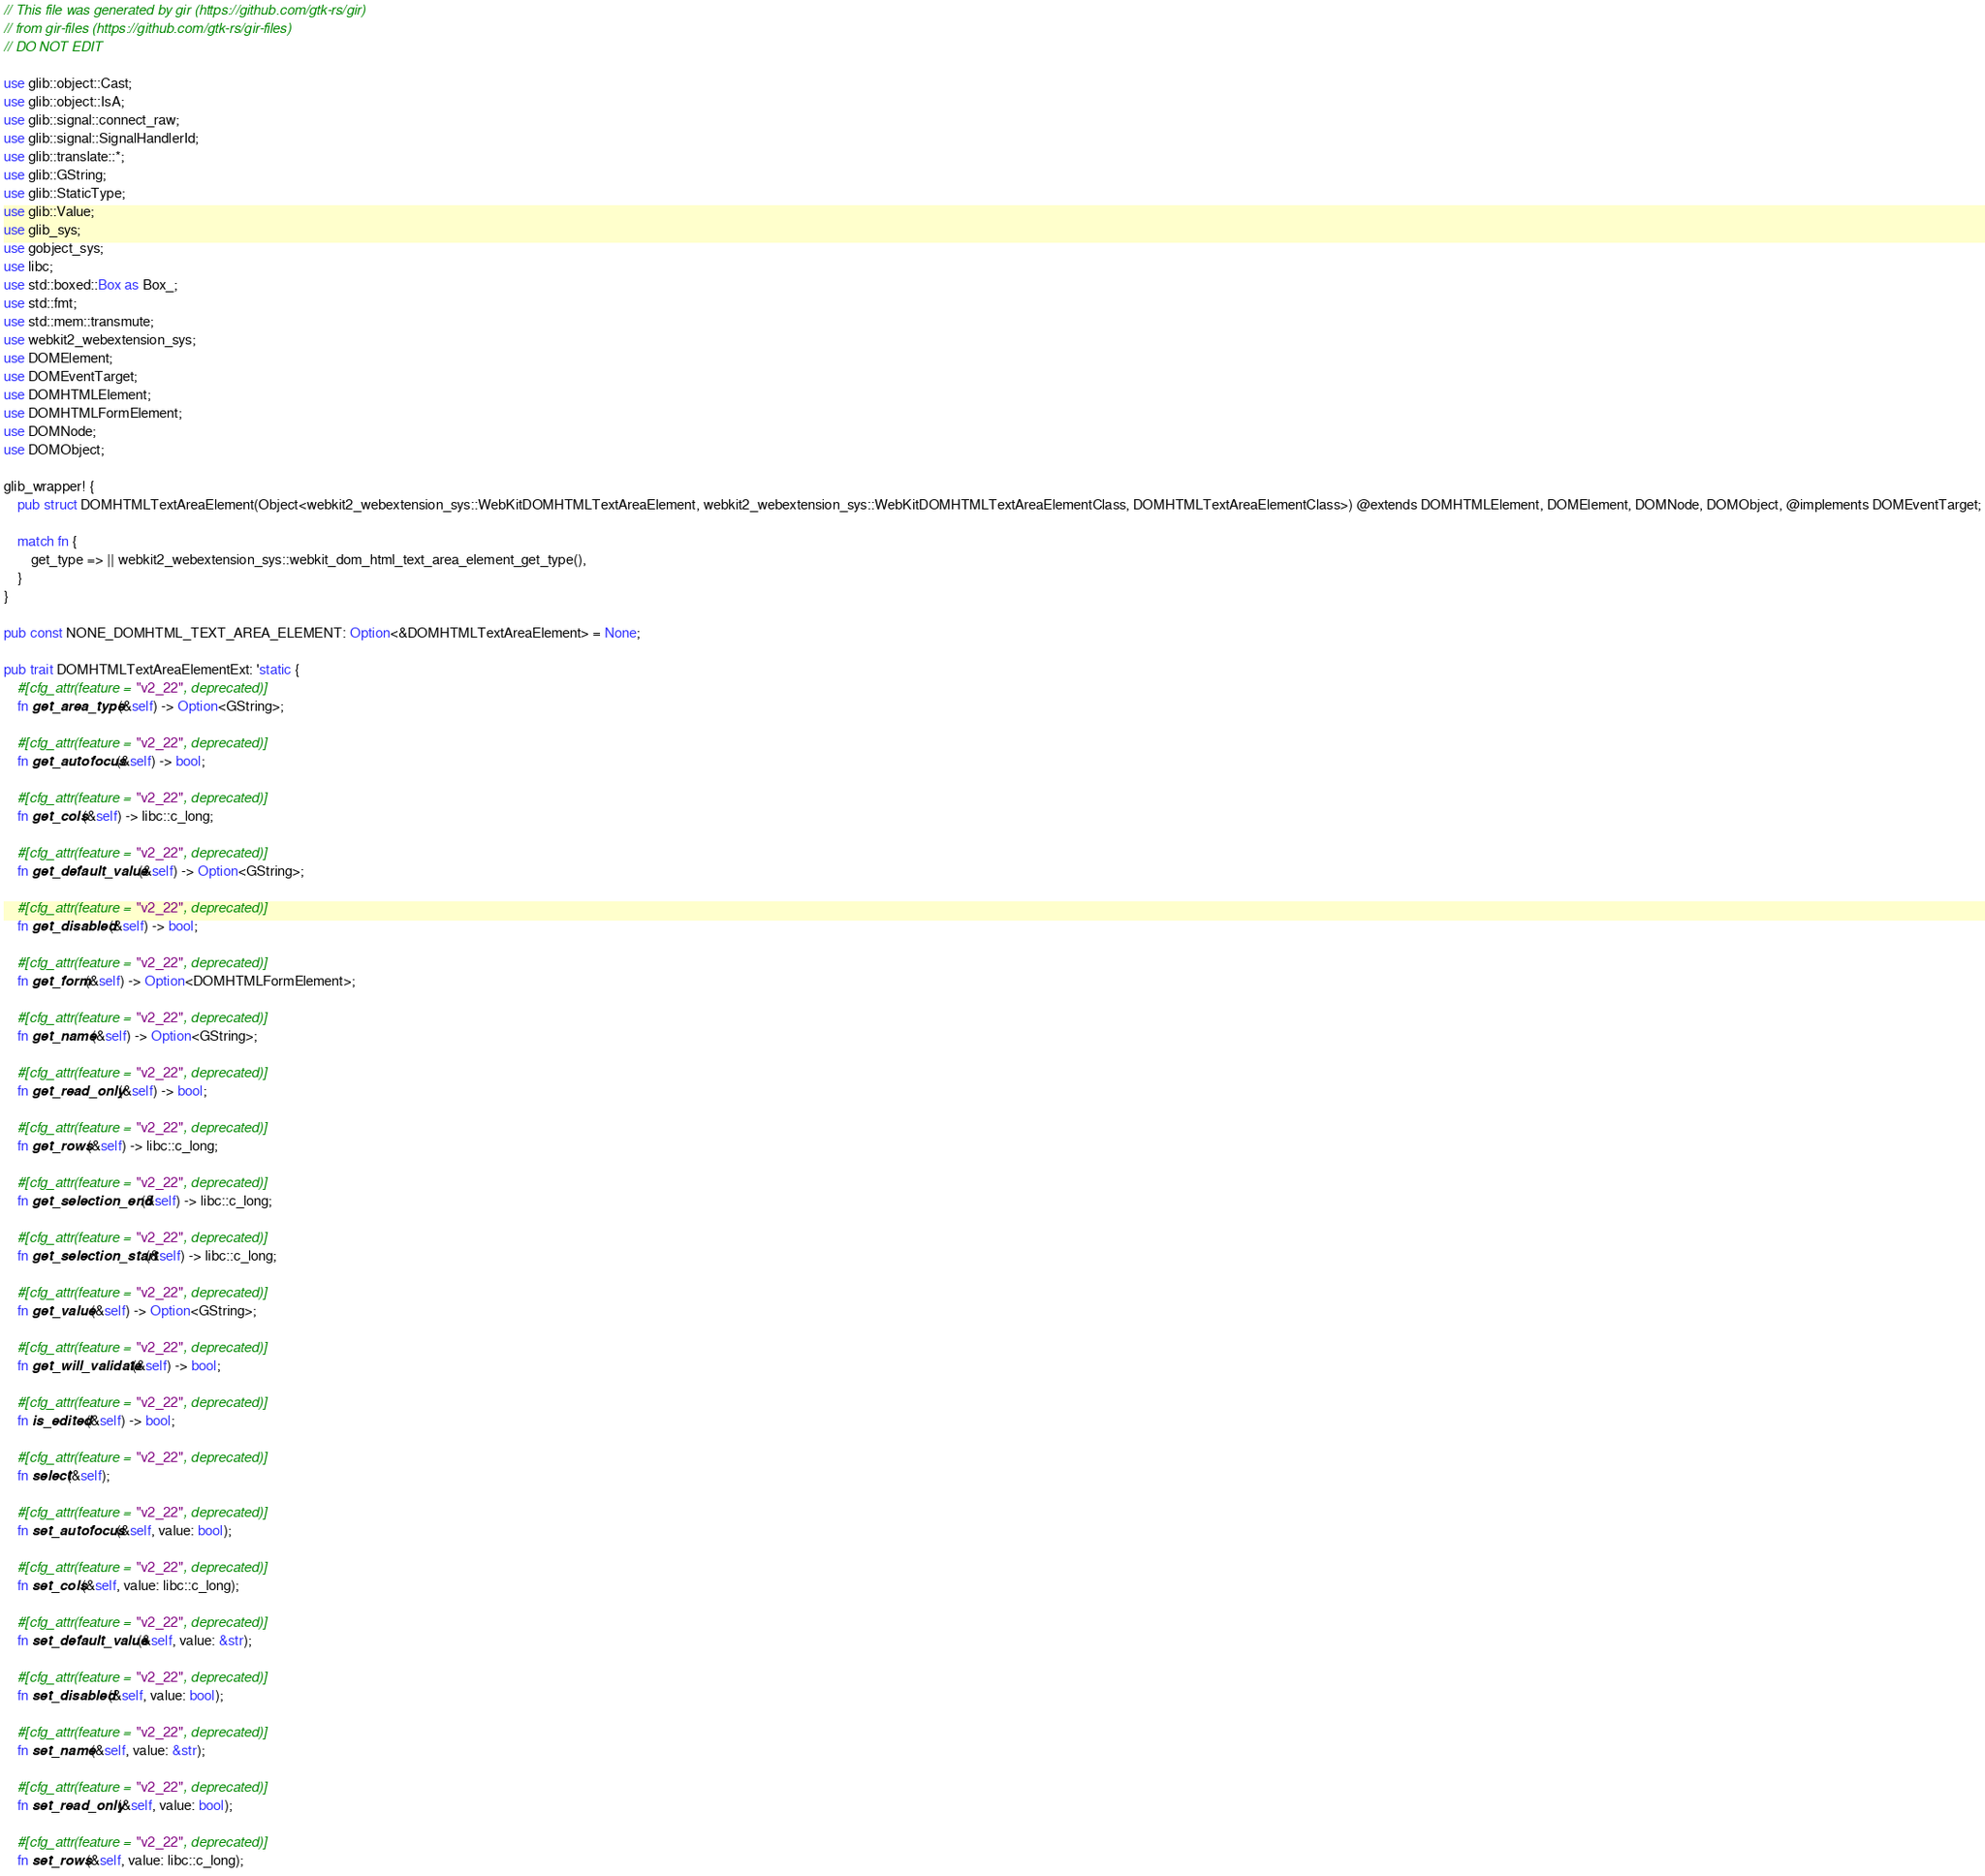<code> <loc_0><loc_0><loc_500><loc_500><_Rust_>// This file was generated by gir (https://github.com/gtk-rs/gir)
// from gir-files (https://github.com/gtk-rs/gir-files)
// DO NOT EDIT

use glib::object::Cast;
use glib::object::IsA;
use glib::signal::connect_raw;
use glib::signal::SignalHandlerId;
use glib::translate::*;
use glib::GString;
use glib::StaticType;
use glib::Value;
use glib_sys;
use gobject_sys;
use libc;
use std::boxed::Box as Box_;
use std::fmt;
use std::mem::transmute;
use webkit2_webextension_sys;
use DOMElement;
use DOMEventTarget;
use DOMHTMLElement;
use DOMHTMLFormElement;
use DOMNode;
use DOMObject;

glib_wrapper! {
    pub struct DOMHTMLTextAreaElement(Object<webkit2_webextension_sys::WebKitDOMHTMLTextAreaElement, webkit2_webextension_sys::WebKitDOMHTMLTextAreaElementClass, DOMHTMLTextAreaElementClass>) @extends DOMHTMLElement, DOMElement, DOMNode, DOMObject, @implements DOMEventTarget;

    match fn {
        get_type => || webkit2_webextension_sys::webkit_dom_html_text_area_element_get_type(),
    }
}

pub const NONE_DOMHTML_TEXT_AREA_ELEMENT: Option<&DOMHTMLTextAreaElement> = None;

pub trait DOMHTMLTextAreaElementExt: 'static {
    #[cfg_attr(feature = "v2_22", deprecated)]
    fn get_area_type(&self) -> Option<GString>;

    #[cfg_attr(feature = "v2_22", deprecated)]
    fn get_autofocus(&self) -> bool;

    #[cfg_attr(feature = "v2_22", deprecated)]
    fn get_cols(&self) -> libc::c_long;

    #[cfg_attr(feature = "v2_22", deprecated)]
    fn get_default_value(&self) -> Option<GString>;

    #[cfg_attr(feature = "v2_22", deprecated)]
    fn get_disabled(&self) -> bool;

    #[cfg_attr(feature = "v2_22", deprecated)]
    fn get_form(&self) -> Option<DOMHTMLFormElement>;

    #[cfg_attr(feature = "v2_22", deprecated)]
    fn get_name(&self) -> Option<GString>;

    #[cfg_attr(feature = "v2_22", deprecated)]
    fn get_read_only(&self) -> bool;

    #[cfg_attr(feature = "v2_22", deprecated)]
    fn get_rows(&self) -> libc::c_long;

    #[cfg_attr(feature = "v2_22", deprecated)]
    fn get_selection_end(&self) -> libc::c_long;

    #[cfg_attr(feature = "v2_22", deprecated)]
    fn get_selection_start(&self) -> libc::c_long;

    #[cfg_attr(feature = "v2_22", deprecated)]
    fn get_value(&self) -> Option<GString>;

    #[cfg_attr(feature = "v2_22", deprecated)]
    fn get_will_validate(&self) -> bool;

    #[cfg_attr(feature = "v2_22", deprecated)]
    fn is_edited(&self) -> bool;

    #[cfg_attr(feature = "v2_22", deprecated)]
    fn select(&self);

    #[cfg_attr(feature = "v2_22", deprecated)]
    fn set_autofocus(&self, value: bool);

    #[cfg_attr(feature = "v2_22", deprecated)]
    fn set_cols(&self, value: libc::c_long);

    #[cfg_attr(feature = "v2_22", deprecated)]
    fn set_default_value(&self, value: &str);

    #[cfg_attr(feature = "v2_22", deprecated)]
    fn set_disabled(&self, value: bool);

    #[cfg_attr(feature = "v2_22", deprecated)]
    fn set_name(&self, value: &str);

    #[cfg_attr(feature = "v2_22", deprecated)]
    fn set_read_only(&self, value: bool);

    #[cfg_attr(feature = "v2_22", deprecated)]
    fn set_rows(&self, value: libc::c_long);
</code> 